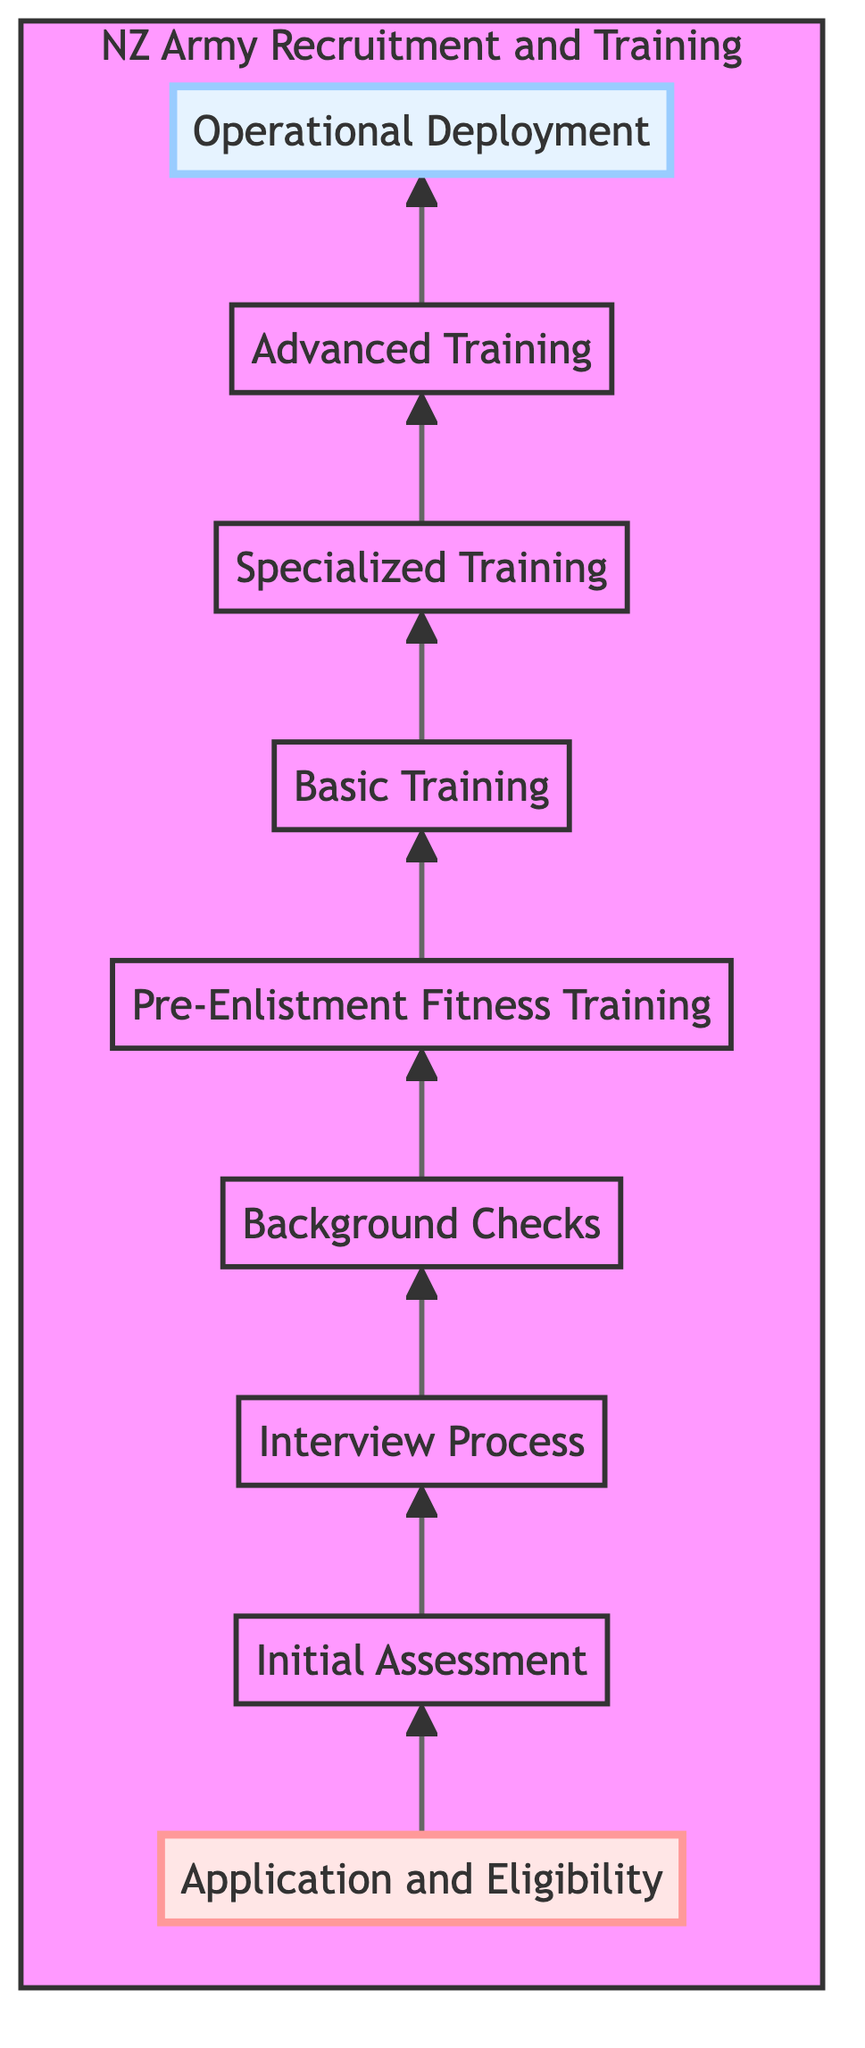What is the first step in the recruitment process? The first step in the recruitment process is "Application and Eligibility," which recruits must complete to demonstrate they meet initial requirements.
Answer: Application and Eligibility How many training levels are present in the hierarchy? The diagram displays eight training levels, starting from "Basic Training" up to "Operational Deployment."
Answer: 8 What follows the "Pre-Enlistment Fitness Training"? After "Pre-Enlistment Fitness Training," candidates proceed to "Basic Training," where they receive foundational military training.
Answer: Basic Training Which step comes immediately before "Operational Deployment"? The step immediately before "Operational Deployment" is "Advanced Training," where soldiers receive advanced tactical and leadership training.
Answer: Advanced Training What is the main focus of "Basic Training"? "Basic Training" primarily focuses on physical fitness, basic combat skills, and instilling Army values in recruits.
Answer: Physical fitness, basic combat skills, Army values What is the relationship between "Interview Process" and "Background Checks"? The "Interview Process" precedes "Background Checks," meaning that candidates must first participate in interviews before undergoing background checks.
Answer: Interview Process --> Background Checks Which training focuses on specialized roles? "Specialized Training" is the step that focuses on the specific roles assigned to recruits, such as infantry, engineering, or communications.
Answer: Specialized Training How many steps are there from "Application and Eligibility" to "Operational Deployment"? There are nine steps in total from "Application and Eligibility" up to "Operational Deployment," counting each level in the flow chart.
Answer: 9 What is the last stage of the recruitment and training process? The last stage in the recruitment and training process is "Operational Deployment," where soldiers are assigned to units and can engage in missions.
Answer: Operational Deployment 